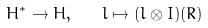Convert formula to latex. <formula><loc_0><loc_0><loc_500><loc_500>H ^ { * } \to H , \quad l \mapsto ( l \otimes I ) ( R )</formula> 